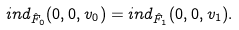<formula> <loc_0><loc_0><loc_500><loc_500>i n d _ { \hat { F } _ { 0 } } ( 0 , 0 , v _ { 0 } ) = i n d _ { \hat { F } _ { 1 } } ( 0 , 0 , v _ { 1 } ) .</formula> 